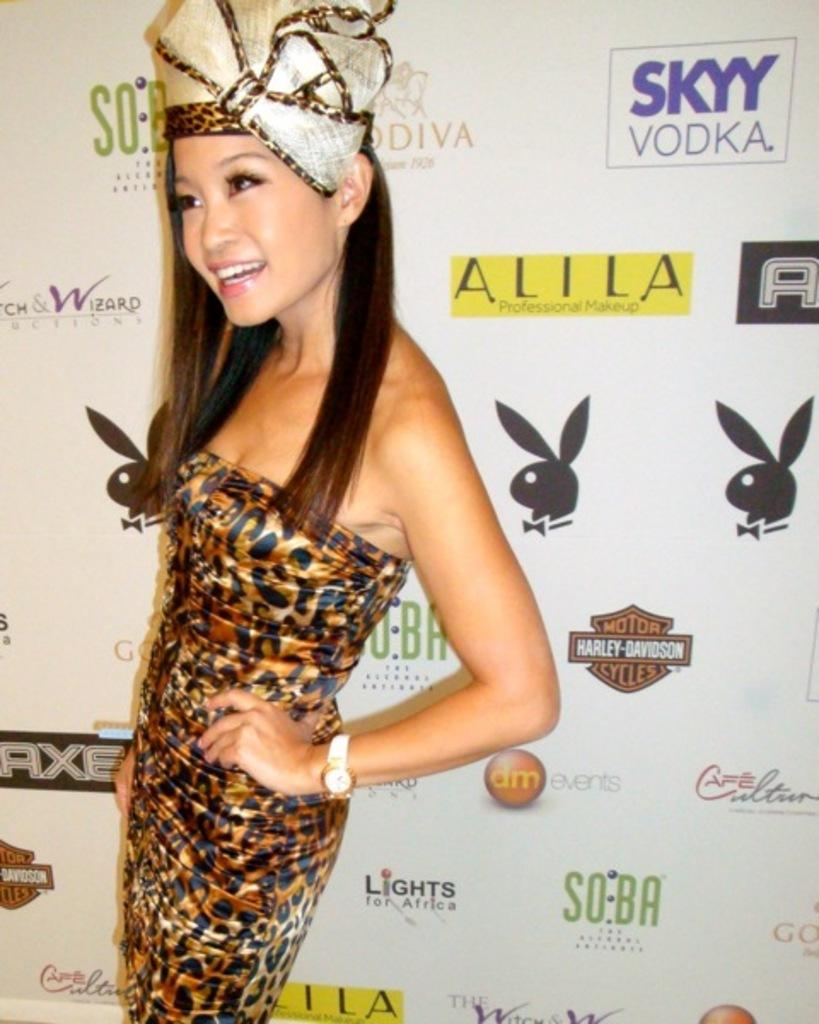What is the main subject of the image? The main subject of the image is a lady. What is the lady doing in the image? The lady is standing and smiling in the image. What is the lady wearing on her head? The lady is wearing a turban on her head. What can be seen behind the lady in the image? There is a banner behind the lady. What is on the banner? The banner has images, logos, and text on it. What type of silver skin can be seen on the lady's arm in the image? There is no silver skin visible on the lady's arm in the image. What is the lady doing with the roll in the image? There is no roll present in the image. 